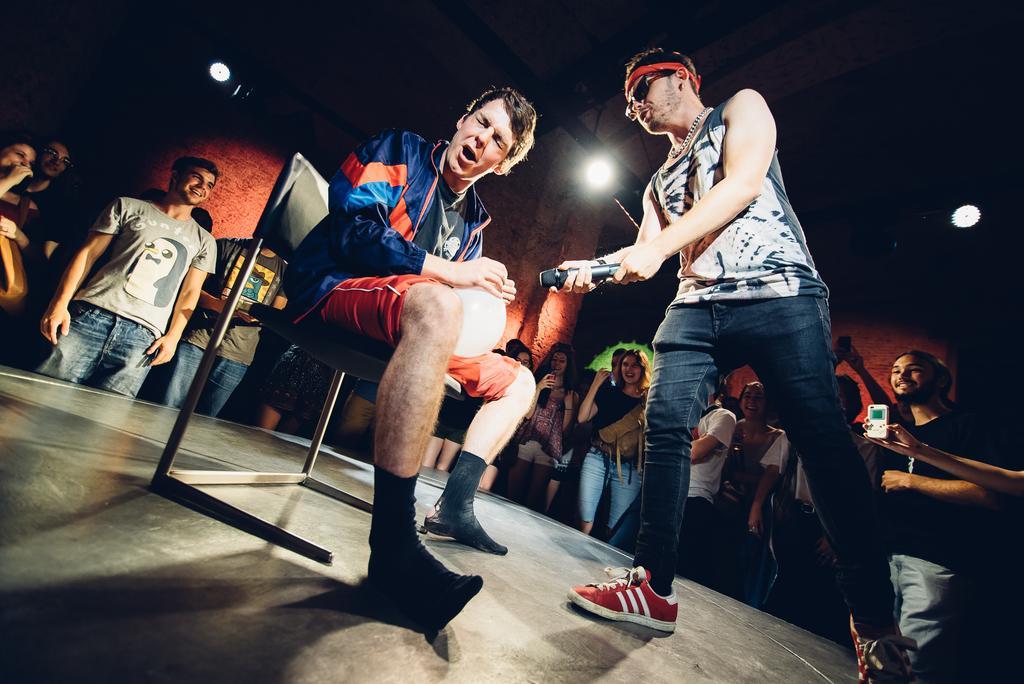Could you give a brief overview of what you see in this image? In this picture I can see a person is sitting on a chair and other person is holding microphone in the hand. In the background I can see people are standing beside a stage. I can also see lights in the background. 